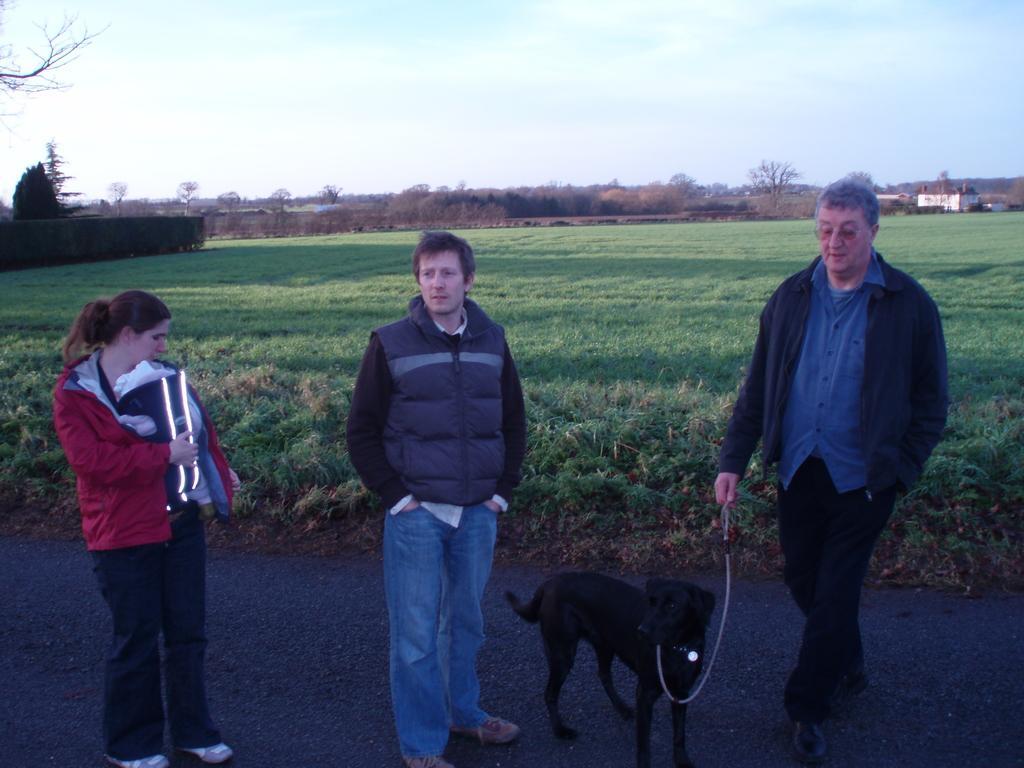In one or two sentences, can you explain what this image depicts? In this picture there are three persons one, two, three, one is a lady among them, a lady is holding the baby and the person who is standing at the right side of the image it seems to be walking by holding the leach of the dog and the person who is standing in the middle of the image is watching in front of the direction and the area where they were stood it seems to be greenery and there is a building at the right side of the image on top right corner. 